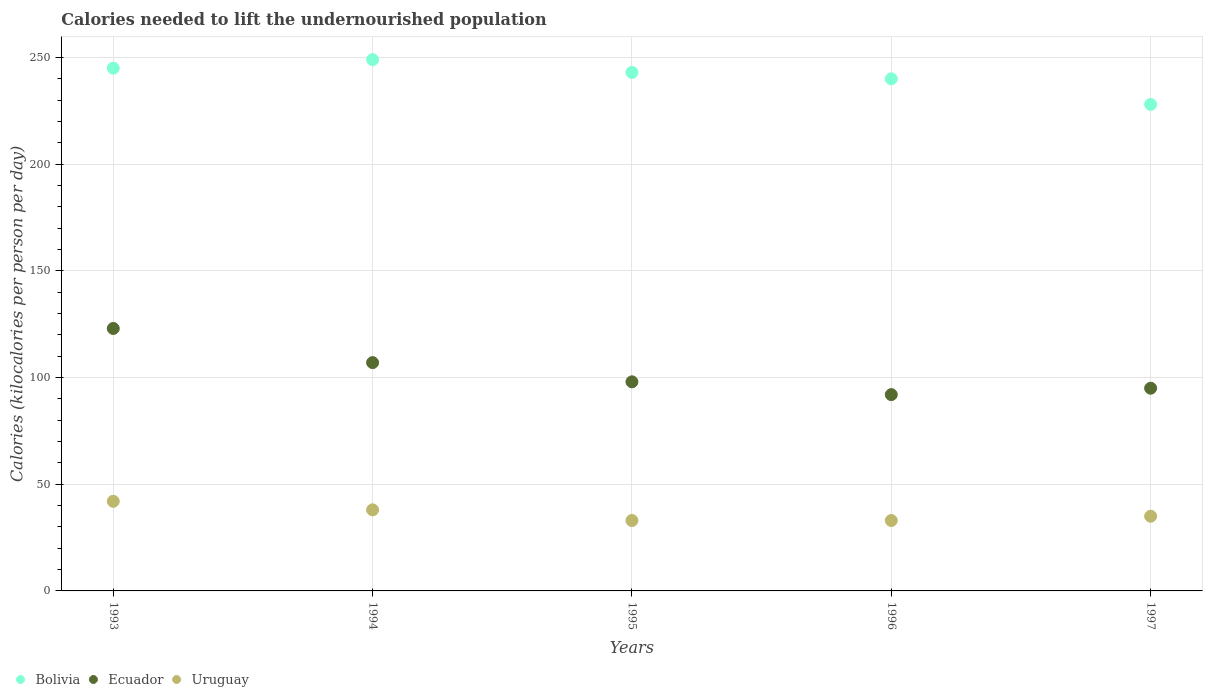What is the total calories needed to lift the undernourished population in Bolivia in 1996?
Your answer should be compact. 240. Across all years, what is the maximum total calories needed to lift the undernourished population in Uruguay?
Offer a very short reply. 42. Across all years, what is the minimum total calories needed to lift the undernourished population in Bolivia?
Give a very brief answer. 228. In which year was the total calories needed to lift the undernourished population in Uruguay maximum?
Your answer should be very brief. 1993. In which year was the total calories needed to lift the undernourished population in Ecuador minimum?
Your response must be concise. 1996. What is the total total calories needed to lift the undernourished population in Bolivia in the graph?
Provide a succinct answer. 1205. What is the difference between the total calories needed to lift the undernourished population in Uruguay in 1994 and that in 1996?
Your response must be concise. 5. What is the difference between the total calories needed to lift the undernourished population in Ecuador in 1997 and the total calories needed to lift the undernourished population in Bolivia in 1996?
Give a very brief answer. -145. What is the average total calories needed to lift the undernourished population in Uruguay per year?
Ensure brevity in your answer.  36.2. In the year 1995, what is the difference between the total calories needed to lift the undernourished population in Ecuador and total calories needed to lift the undernourished population in Bolivia?
Provide a succinct answer. -145. In how many years, is the total calories needed to lift the undernourished population in Uruguay greater than 80 kilocalories?
Offer a very short reply. 0. What is the ratio of the total calories needed to lift the undernourished population in Uruguay in 1993 to that in 1997?
Give a very brief answer. 1.2. What is the difference between the highest and the second highest total calories needed to lift the undernourished population in Uruguay?
Your answer should be compact. 4. What is the difference between the highest and the lowest total calories needed to lift the undernourished population in Bolivia?
Provide a succinct answer. 21. Is it the case that in every year, the sum of the total calories needed to lift the undernourished population in Uruguay and total calories needed to lift the undernourished population in Bolivia  is greater than the total calories needed to lift the undernourished population in Ecuador?
Your answer should be very brief. Yes. Does the total calories needed to lift the undernourished population in Bolivia monotonically increase over the years?
Offer a terse response. No. Is the total calories needed to lift the undernourished population in Uruguay strictly greater than the total calories needed to lift the undernourished population in Bolivia over the years?
Keep it short and to the point. No. Is the total calories needed to lift the undernourished population in Bolivia strictly less than the total calories needed to lift the undernourished population in Uruguay over the years?
Your answer should be very brief. No. How many dotlines are there?
Keep it short and to the point. 3. How many years are there in the graph?
Give a very brief answer. 5. What is the difference between two consecutive major ticks on the Y-axis?
Your response must be concise. 50. Does the graph contain any zero values?
Give a very brief answer. No. Does the graph contain grids?
Make the answer very short. Yes. How are the legend labels stacked?
Your response must be concise. Horizontal. What is the title of the graph?
Offer a very short reply. Calories needed to lift the undernourished population. Does "Sint Maarten (Dutch part)" appear as one of the legend labels in the graph?
Ensure brevity in your answer.  No. What is the label or title of the Y-axis?
Keep it short and to the point. Calories (kilocalories per person per day). What is the Calories (kilocalories per person per day) in Bolivia in 1993?
Make the answer very short. 245. What is the Calories (kilocalories per person per day) of Ecuador in 1993?
Give a very brief answer. 123. What is the Calories (kilocalories per person per day) of Uruguay in 1993?
Provide a short and direct response. 42. What is the Calories (kilocalories per person per day) of Bolivia in 1994?
Your answer should be very brief. 249. What is the Calories (kilocalories per person per day) of Ecuador in 1994?
Your answer should be very brief. 107. What is the Calories (kilocalories per person per day) in Bolivia in 1995?
Make the answer very short. 243. What is the Calories (kilocalories per person per day) in Ecuador in 1995?
Give a very brief answer. 98. What is the Calories (kilocalories per person per day) in Bolivia in 1996?
Provide a succinct answer. 240. What is the Calories (kilocalories per person per day) of Ecuador in 1996?
Make the answer very short. 92. What is the Calories (kilocalories per person per day) in Uruguay in 1996?
Keep it short and to the point. 33. What is the Calories (kilocalories per person per day) of Bolivia in 1997?
Offer a terse response. 228. Across all years, what is the maximum Calories (kilocalories per person per day) in Bolivia?
Give a very brief answer. 249. Across all years, what is the maximum Calories (kilocalories per person per day) in Ecuador?
Provide a succinct answer. 123. Across all years, what is the maximum Calories (kilocalories per person per day) of Uruguay?
Keep it short and to the point. 42. Across all years, what is the minimum Calories (kilocalories per person per day) in Bolivia?
Offer a terse response. 228. Across all years, what is the minimum Calories (kilocalories per person per day) of Ecuador?
Provide a succinct answer. 92. What is the total Calories (kilocalories per person per day) in Bolivia in the graph?
Your answer should be compact. 1205. What is the total Calories (kilocalories per person per day) in Ecuador in the graph?
Ensure brevity in your answer.  515. What is the total Calories (kilocalories per person per day) of Uruguay in the graph?
Provide a succinct answer. 181. What is the difference between the Calories (kilocalories per person per day) of Ecuador in 1993 and that in 1994?
Offer a terse response. 16. What is the difference between the Calories (kilocalories per person per day) of Bolivia in 1993 and that in 1995?
Provide a short and direct response. 2. What is the difference between the Calories (kilocalories per person per day) of Uruguay in 1993 and that in 1995?
Ensure brevity in your answer.  9. What is the difference between the Calories (kilocalories per person per day) of Bolivia in 1993 and that in 1996?
Provide a succinct answer. 5. What is the difference between the Calories (kilocalories per person per day) in Ecuador in 1993 and that in 1996?
Give a very brief answer. 31. What is the difference between the Calories (kilocalories per person per day) of Uruguay in 1993 and that in 1997?
Ensure brevity in your answer.  7. What is the difference between the Calories (kilocalories per person per day) in Bolivia in 1994 and that in 1995?
Offer a terse response. 6. What is the difference between the Calories (kilocalories per person per day) in Uruguay in 1994 and that in 1996?
Give a very brief answer. 5. What is the difference between the Calories (kilocalories per person per day) in Bolivia in 1994 and that in 1997?
Your answer should be compact. 21. What is the difference between the Calories (kilocalories per person per day) of Ecuador in 1994 and that in 1997?
Provide a succinct answer. 12. What is the difference between the Calories (kilocalories per person per day) of Uruguay in 1994 and that in 1997?
Keep it short and to the point. 3. What is the difference between the Calories (kilocalories per person per day) of Bolivia in 1995 and that in 1996?
Offer a terse response. 3. What is the difference between the Calories (kilocalories per person per day) in Ecuador in 1995 and that in 1997?
Your answer should be very brief. 3. What is the difference between the Calories (kilocalories per person per day) of Bolivia in 1993 and the Calories (kilocalories per person per day) of Ecuador in 1994?
Keep it short and to the point. 138. What is the difference between the Calories (kilocalories per person per day) of Bolivia in 1993 and the Calories (kilocalories per person per day) of Uruguay in 1994?
Keep it short and to the point. 207. What is the difference between the Calories (kilocalories per person per day) of Bolivia in 1993 and the Calories (kilocalories per person per day) of Ecuador in 1995?
Provide a succinct answer. 147. What is the difference between the Calories (kilocalories per person per day) in Bolivia in 1993 and the Calories (kilocalories per person per day) in Uruguay in 1995?
Offer a terse response. 212. What is the difference between the Calories (kilocalories per person per day) of Bolivia in 1993 and the Calories (kilocalories per person per day) of Ecuador in 1996?
Offer a very short reply. 153. What is the difference between the Calories (kilocalories per person per day) in Bolivia in 1993 and the Calories (kilocalories per person per day) in Uruguay in 1996?
Your answer should be very brief. 212. What is the difference between the Calories (kilocalories per person per day) in Ecuador in 1993 and the Calories (kilocalories per person per day) in Uruguay in 1996?
Provide a succinct answer. 90. What is the difference between the Calories (kilocalories per person per day) in Bolivia in 1993 and the Calories (kilocalories per person per day) in Ecuador in 1997?
Give a very brief answer. 150. What is the difference between the Calories (kilocalories per person per day) of Bolivia in 1993 and the Calories (kilocalories per person per day) of Uruguay in 1997?
Your answer should be very brief. 210. What is the difference between the Calories (kilocalories per person per day) in Bolivia in 1994 and the Calories (kilocalories per person per day) in Ecuador in 1995?
Give a very brief answer. 151. What is the difference between the Calories (kilocalories per person per day) of Bolivia in 1994 and the Calories (kilocalories per person per day) of Uruguay in 1995?
Your answer should be very brief. 216. What is the difference between the Calories (kilocalories per person per day) in Ecuador in 1994 and the Calories (kilocalories per person per day) in Uruguay in 1995?
Offer a very short reply. 74. What is the difference between the Calories (kilocalories per person per day) of Bolivia in 1994 and the Calories (kilocalories per person per day) of Ecuador in 1996?
Your answer should be compact. 157. What is the difference between the Calories (kilocalories per person per day) in Bolivia in 1994 and the Calories (kilocalories per person per day) in Uruguay in 1996?
Your response must be concise. 216. What is the difference between the Calories (kilocalories per person per day) in Ecuador in 1994 and the Calories (kilocalories per person per day) in Uruguay in 1996?
Provide a succinct answer. 74. What is the difference between the Calories (kilocalories per person per day) of Bolivia in 1994 and the Calories (kilocalories per person per day) of Ecuador in 1997?
Make the answer very short. 154. What is the difference between the Calories (kilocalories per person per day) in Bolivia in 1994 and the Calories (kilocalories per person per day) in Uruguay in 1997?
Ensure brevity in your answer.  214. What is the difference between the Calories (kilocalories per person per day) of Ecuador in 1994 and the Calories (kilocalories per person per day) of Uruguay in 1997?
Keep it short and to the point. 72. What is the difference between the Calories (kilocalories per person per day) of Bolivia in 1995 and the Calories (kilocalories per person per day) of Ecuador in 1996?
Offer a terse response. 151. What is the difference between the Calories (kilocalories per person per day) in Bolivia in 1995 and the Calories (kilocalories per person per day) in Uruguay in 1996?
Your response must be concise. 210. What is the difference between the Calories (kilocalories per person per day) of Bolivia in 1995 and the Calories (kilocalories per person per day) of Ecuador in 1997?
Your answer should be compact. 148. What is the difference between the Calories (kilocalories per person per day) in Bolivia in 1995 and the Calories (kilocalories per person per day) in Uruguay in 1997?
Make the answer very short. 208. What is the difference between the Calories (kilocalories per person per day) of Bolivia in 1996 and the Calories (kilocalories per person per day) of Ecuador in 1997?
Make the answer very short. 145. What is the difference between the Calories (kilocalories per person per day) in Bolivia in 1996 and the Calories (kilocalories per person per day) in Uruguay in 1997?
Ensure brevity in your answer.  205. What is the difference between the Calories (kilocalories per person per day) in Ecuador in 1996 and the Calories (kilocalories per person per day) in Uruguay in 1997?
Provide a short and direct response. 57. What is the average Calories (kilocalories per person per day) of Bolivia per year?
Give a very brief answer. 241. What is the average Calories (kilocalories per person per day) in Ecuador per year?
Offer a terse response. 103. What is the average Calories (kilocalories per person per day) in Uruguay per year?
Make the answer very short. 36.2. In the year 1993, what is the difference between the Calories (kilocalories per person per day) in Bolivia and Calories (kilocalories per person per day) in Ecuador?
Ensure brevity in your answer.  122. In the year 1993, what is the difference between the Calories (kilocalories per person per day) in Bolivia and Calories (kilocalories per person per day) in Uruguay?
Ensure brevity in your answer.  203. In the year 1994, what is the difference between the Calories (kilocalories per person per day) in Bolivia and Calories (kilocalories per person per day) in Ecuador?
Provide a succinct answer. 142. In the year 1994, what is the difference between the Calories (kilocalories per person per day) of Bolivia and Calories (kilocalories per person per day) of Uruguay?
Ensure brevity in your answer.  211. In the year 1994, what is the difference between the Calories (kilocalories per person per day) in Ecuador and Calories (kilocalories per person per day) in Uruguay?
Make the answer very short. 69. In the year 1995, what is the difference between the Calories (kilocalories per person per day) of Bolivia and Calories (kilocalories per person per day) of Ecuador?
Offer a terse response. 145. In the year 1995, what is the difference between the Calories (kilocalories per person per day) in Bolivia and Calories (kilocalories per person per day) in Uruguay?
Ensure brevity in your answer.  210. In the year 1995, what is the difference between the Calories (kilocalories per person per day) in Ecuador and Calories (kilocalories per person per day) in Uruguay?
Provide a succinct answer. 65. In the year 1996, what is the difference between the Calories (kilocalories per person per day) of Bolivia and Calories (kilocalories per person per day) of Ecuador?
Provide a succinct answer. 148. In the year 1996, what is the difference between the Calories (kilocalories per person per day) of Bolivia and Calories (kilocalories per person per day) of Uruguay?
Offer a very short reply. 207. In the year 1997, what is the difference between the Calories (kilocalories per person per day) in Bolivia and Calories (kilocalories per person per day) in Ecuador?
Your answer should be compact. 133. In the year 1997, what is the difference between the Calories (kilocalories per person per day) of Bolivia and Calories (kilocalories per person per day) of Uruguay?
Give a very brief answer. 193. What is the ratio of the Calories (kilocalories per person per day) of Bolivia in 1993 to that in 1994?
Keep it short and to the point. 0.98. What is the ratio of the Calories (kilocalories per person per day) in Ecuador in 1993 to that in 1994?
Keep it short and to the point. 1.15. What is the ratio of the Calories (kilocalories per person per day) of Uruguay in 1993 to that in 1994?
Ensure brevity in your answer.  1.11. What is the ratio of the Calories (kilocalories per person per day) of Bolivia in 1993 to that in 1995?
Provide a succinct answer. 1.01. What is the ratio of the Calories (kilocalories per person per day) of Ecuador in 1993 to that in 1995?
Your answer should be very brief. 1.26. What is the ratio of the Calories (kilocalories per person per day) of Uruguay in 1993 to that in 1995?
Your answer should be very brief. 1.27. What is the ratio of the Calories (kilocalories per person per day) of Bolivia in 1993 to that in 1996?
Your response must be concise. 1.02. What is the ratio of the Calories (kilocalories per person per day) in Ecuador in 1993 to that in 1996?
Your response must be concise. 1.34. What is the ratio of the Calories (kilocalories per person per day) in Uruguay in 1993 to that in 1996?
Offer a terse response. 1.27. What is the ratio of the Calories (kilocalories per person per day) in Bolivia in 1993 to that in 1997?
Provide a short and direct response. 1.07. What is the ratio of the Calories (kilocalories per person per day) of Ecuador in 1993 to that in 1997?
Offer a terse response. 1.29. What is the ratio of the Calories (kilocalories per person per day) of Bolivia in 1994 to that in 1995?
Your answer should be very brief. 1.02. What is the ratio of the Calories (kilocalories per person per day) in Ecuador in 1994 to that in 1995?
Provide a succinct answer. 1.09. What is the ratio of the Calories (kilocalories per person per day) of Uruguay in 1994 to that in 1995?
Offer a terse response. 1.15. What is the ratio of the Calories (kilocalories per person per day) of Bolivia in 1994 to that in 1996?
Provide a short and direct response. 1.04. What is the ratio of the Calories (kilocalories per person per day) of Ecuador in 1994 to that in 1996?
Give a very brief answer. 1.16. What is the ratio of the Calories (kilocalories per person per day) of Uruguay in 1994 to that in 1996?
Your answer should be very brief. 1.15. What is the ratio of the Calories (kilocalories per person per day) in Bolivia in 1994 to that in 1997?
Offer a very short reply. 1.09. What is the ratio of the Calories (kilocalories per person per day) in Ecuador in 1994 to that in 1997?
Ensure brevity in your answer.  1.13. What is the ratio of the Calories (kilocalories per person per day) of Uruguay in 1994 to that in 1997?
Make the answer very short. 1.09. What is the ratio of the Calories (kilocalories per person per day) in Bolivia in 1995 to that in 1996?
Offer a very short reply. 1.01. What is the ratio of the Calories (kilocalories per person per day) in Ecuador in 1995 to that in 1996?
Offer a terse response. 1.07. What is the ratio of the Calories (kilocalories per person per day) in Uruguay in 1995 to that in 1996?
Your response must be concise. 1. What is the ratio of the Calories (kilocalories per person per day) of Bolivia in 1995 to that in 1997?
Offer a very short reply. 1.07. What is the ratio of the Calories (kilocalories per person per day) of Ecuador in 1995 to that in 1997?
Ensure brevity in your answer.  1.03. What is the ratio of the Calories (kilocalories per person per day) in Uruguay in 1995 to that in 1997?
Your response must be concise. 0.94. What is the ratio of the Calories (kilocalories per person per day) in Bolivia in 1996 to that in 1997?
Offer a very short reply. 1.05. What is the ratio of the Calories (kilocalories per person per day) of Ecuador in 1996 to that in 1997?
Keep it short and to the point. 0.97. What is the ratio of the Calories (kilocalories per person per day) of Uruguay in 1996 to that in 1997?
Your answer should be very brief. 0.94. What is the difference between the highest and the second highest Calories (kilocalories per person per day) of Ecuador?
Ensure brevity in your answer.  16. What is the difference between the highest and the lowest Calories (kilocalories per person per day) in Bolivia?
Your response must be concise. 21. What is the difference between the highest and the lowest Calories (kilocalories per person per day) in Ecuador?
Provide a succinct answer. 31. What is the difference between the highest and the lowest Calories (kilocalories per person per day) in Uruguay?
Make the answer very short. 9. 